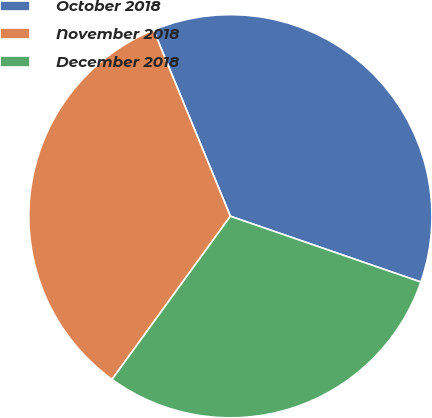Convert chart to OTSL. <chart><loc_0><loc_0><loc_500><loc_500><pie_chart><fcel>October 2018<fcel>November 2018<fcel>December 2018<nl><fcel>36.52%<fcel>33.78%<fcel>29.69%<nl></chart> 